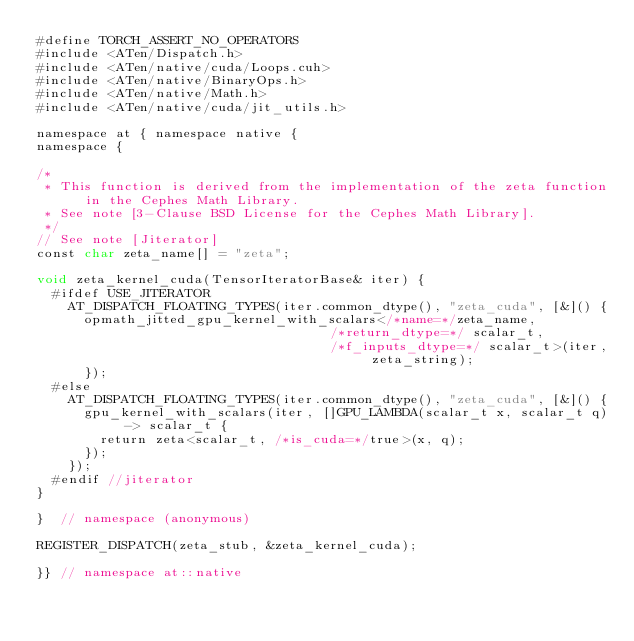Convert code to text. <code><loc_0><loc_0><loc_500><loc_500><_Cuda_>#define TORCH_ASSERT_NO_OPERATORS
#include <ATen/Dispatch.h>
#include <ATen/native/cuda/Loops.cuh>
#include <ATen/native/BinaryOps.h>
#include <ATen/native/Math.h>
#include <ATen/native/cuda/jit_utils.h>

namespace at { namespace native {
namespace {

/*
 * This function is derived from the implementation of the zeta function in the Cephes Math Library.
 * See note [3-Clause BSD License for the Cephes Math Library].
 */
// See note [Jiterator]
const char zeta_name[] = "zeta";

void zeta_kernel_cuda(TensorIteratorBase& iter) {
  #ifdef USE_JITERATOR
    AT_DISPATCH_FLOATING_TYPES(iter.common_dtype(), "zeta_cuda", [&]() {
      opmath_jitted_gpu_kernel_with_scalars</*name=*/zeta_name,
                                     /*return_dtype=*/ scalar_t,
                                     /*f_inputs_dtype=*/ scalar_t>(iter, zeta_string);
      });
  #else
    AT_DISPATCH_FLOATING_TYPES(iter.common_dtype(), "zeta_cuda", [&]() {
      gpu_kernel_with_scalars(iter, []GPU_LAMBDA(scalar_t x, scalar_t q) -> scalar_t {
        return zeta<scalar_t, /*is_cuda=*/true>(x, q);
      });
    });
  #endif //jiterator
}

}  // namespace (anonymous)

REGISTER_DISPATCH(zeta_stub, &zeta_kernel_cuda);

}} // namespace at::native
</code> 